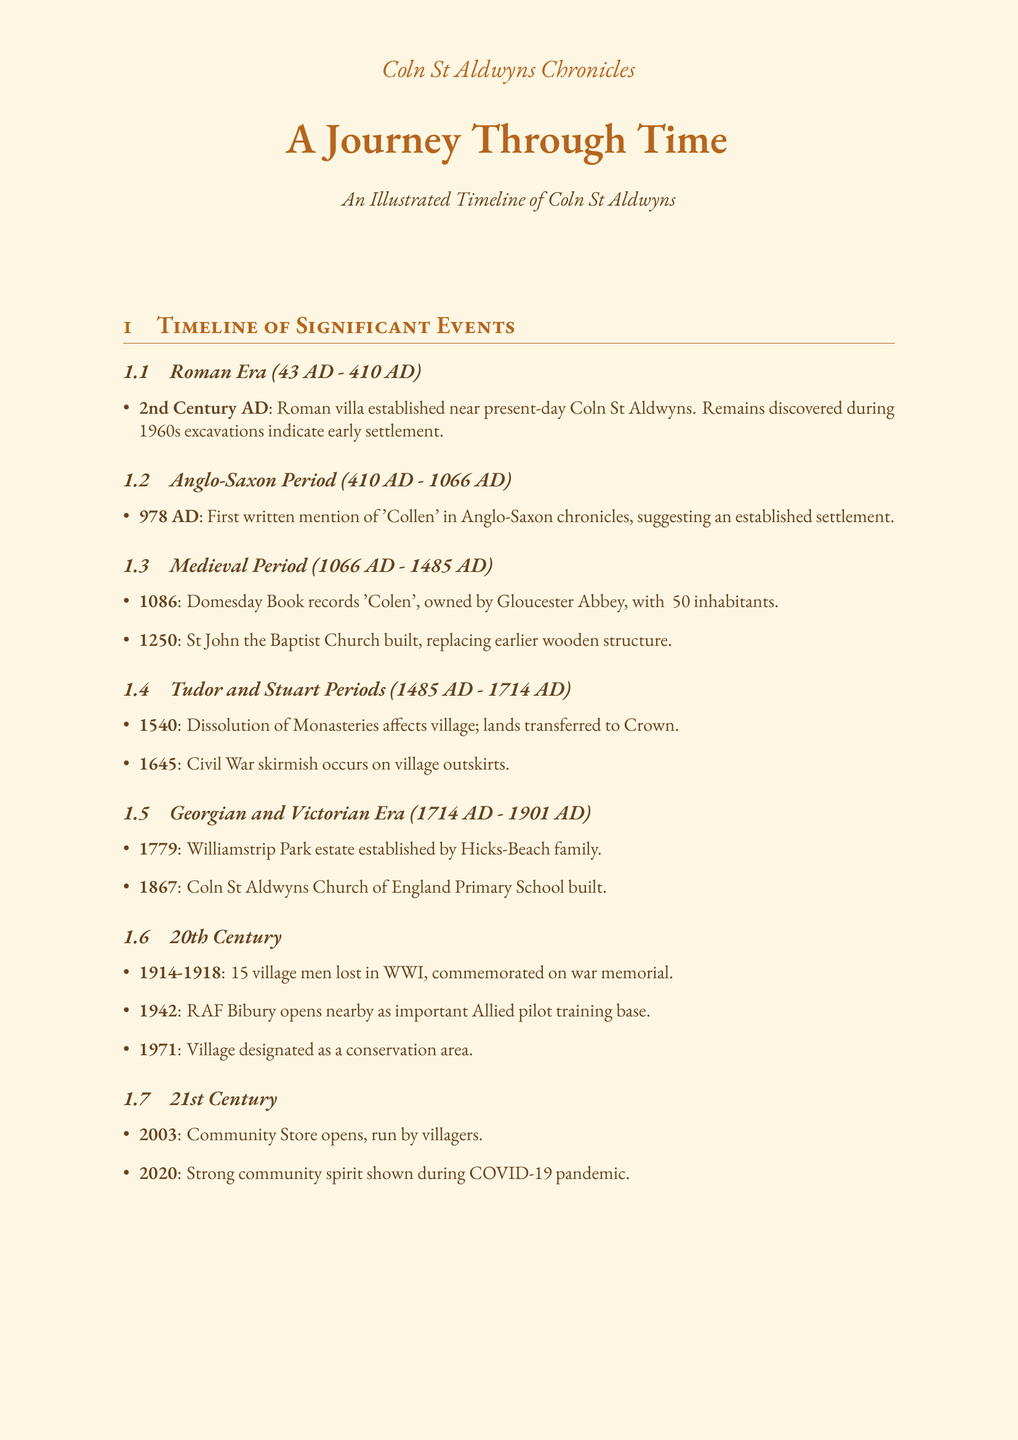What is the first written mention of 'Collen'? The document states the first written mention of 'Collen' occurred in 978 AD in Anglo-Saxon chronicles.
Answer: 978 AD Who owned Coln St Aldwyns according to the Domesday Book? The Domesday Book records that Coln St Aldwyns was owned by the Abbey of Gloucester in 1086.
Answer: Abbey of Gloucester What significant event occurred in Coln St Aldwyns in 1645? A Civil War skirmish occurred near the village in that year.
Answer: Civil War skirmish When was the Coln St Aldwyns Church of England Primary School built? The school was established in 1867, according to the timeline in the document.
Answer: 1867 What major event happened during the years 1914-1918 in Coln St Aldwyns? The document mentions that 15 men from Coln St Aldwyns lost their lives in World War I during this period.
Answer: World War I Who intervened in the Coln Witch Trial of 1612? The progressive-minded local landowner intervened in the witch trial of Mary Burdock.
Answer: Local landowner What was affected by the Great Flood of 1853? The document states that several cottages were destroyed by the flood.
Answer: Several cottages In which year did the Community Store open? According to the timeline, the Community Store was opened in 2003.
Answer: 2003 What kind of operation occurred near Coln St Aldwyns during World War II? A clandestine radio station operated from a farmhouse near the village during WWII.
Answer: Clandestine radio station 